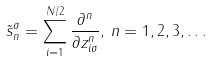<formula> <loc_0><loc_0><loc_500><loc_500>\tilde { s } _ { n } ^ { \sigma } = \sum _ { i = 1 } ^ { N / 2 } \frac { \partial ^ { n } } { \partial z _ { i \sigma } ^ { n } } , \, n = 1 , 2 , 3 , \dots</formula> 